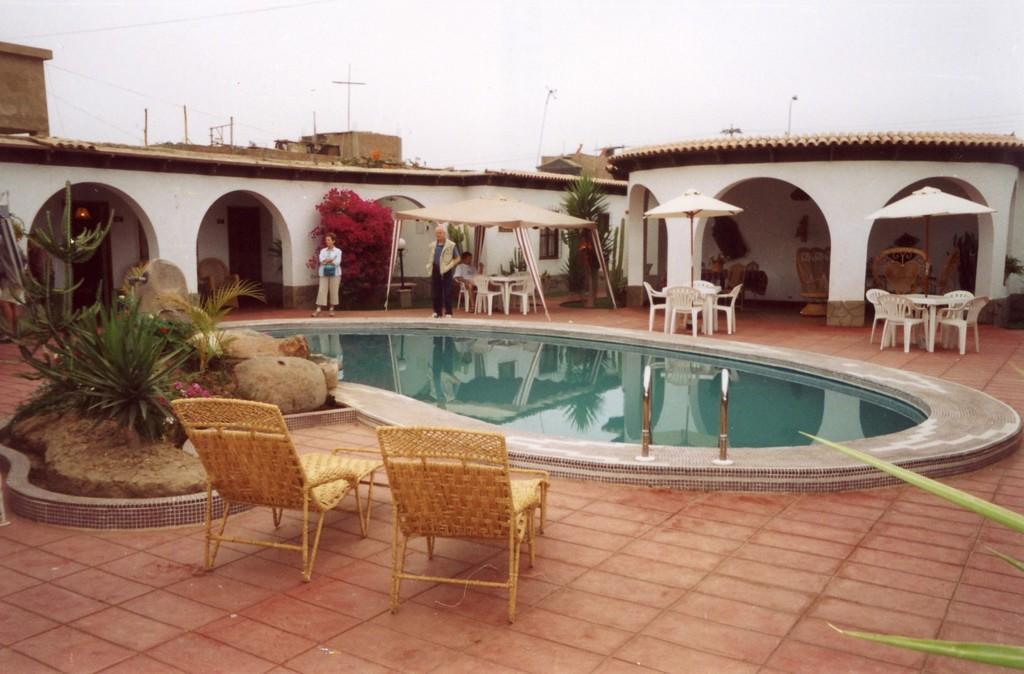Can you describe this image briefly? At the bottom of this image, there are two wooden chairs arranged on the floor. Beside them, there are plants, rocks and grass on the ground. In the background, there is a swimming pool, there are umbrellas arranged, under them there are chairs and tables arranged, there are three persons, one of them is sitting, there are buildings which are having roofs and windows and there are clouds in the sky. 